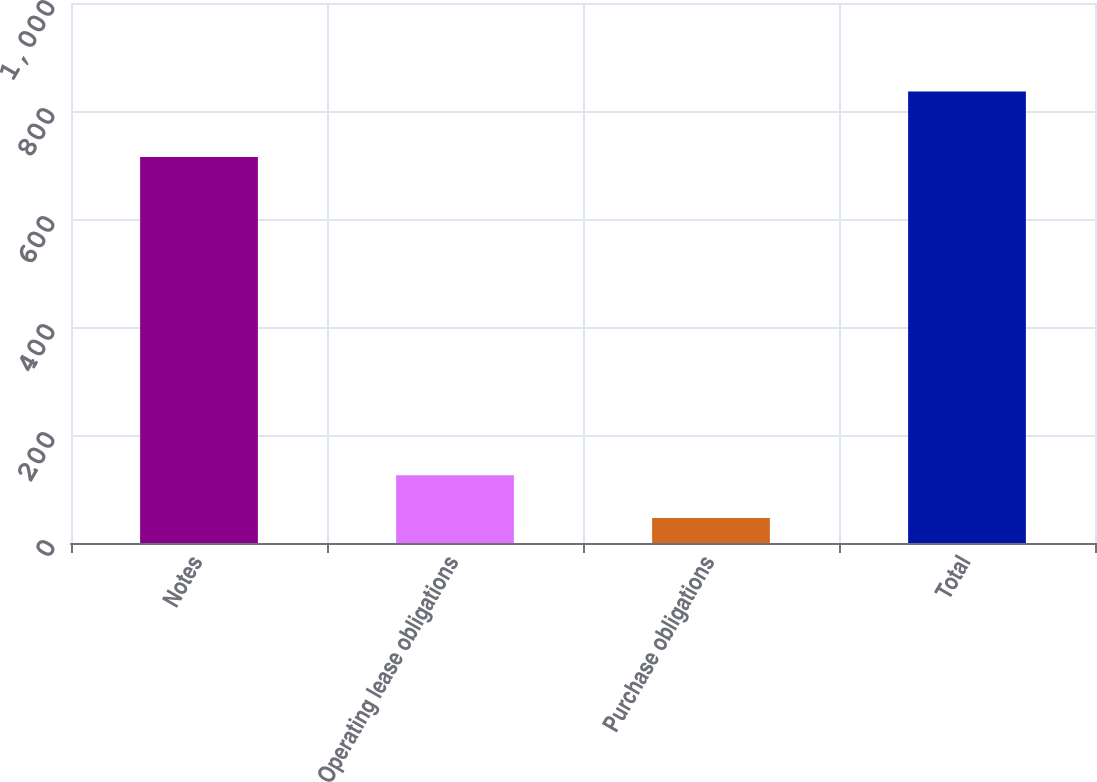Convert chart. <chart><loc_0><loc_0><loc_500><loc_500><bar_chart><fcel>Notes<fcel>Operating lease obligations<fcel>Purchase obligations<fcel>Total<nl><fcel>714.8<fcel>125.46<fcel>46.5<fcel>836.1<nl></chart> 